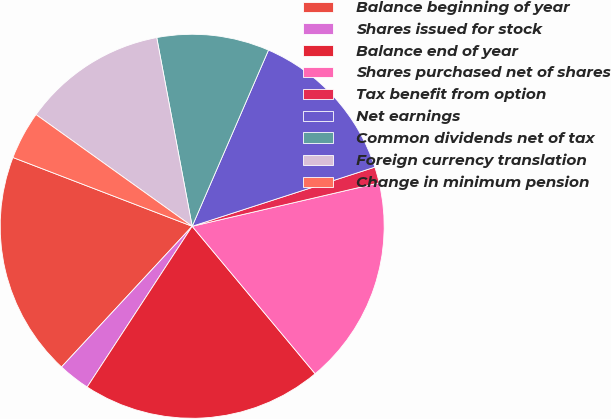Convert chart. <chart><loc_0><loc_0><loc_500><loc_500><pie_chart><fcel>Balance beginning of year<fcel>Shares issued for stock<fcel>Balance end of year<fcel>Shares purchased net of shares<fcel>Tax benefit from option<fcel>Net earnings<fcel>Common dividends net of tax<fcel>Foreign currency translation<fcel>Change in minimum pension<nl><fcel>18.92%<fcel>2.7%<fcel>20.27%<fcel>17.57%<fcel>1.35%<fcel>13.51%<fcel>9.46%<fcel>12.16%<fcel>4.05%<nl></chart> 